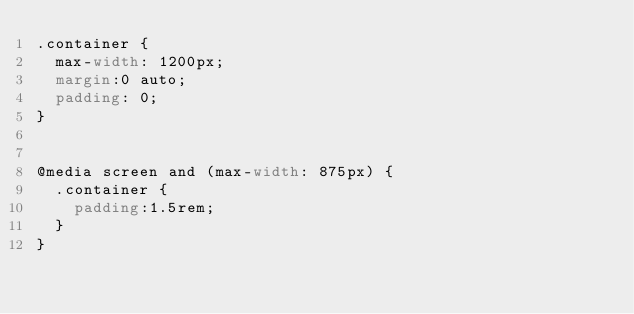<code> <loc_0><loc_0><loc_500><loc_500><_CSS_>.container {
  max-width: 1200px;
  margin:0 auto;
  padding: 0;
}


@media screen and (max-width: 875px) {
  .container {
    padding:1.5rem;
  }
}
</code> 